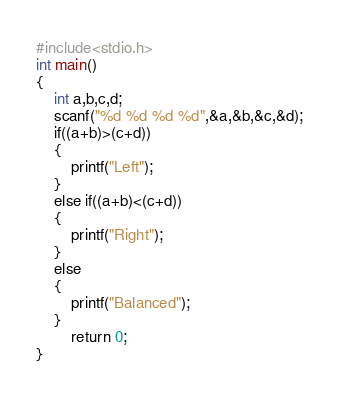Convert code to text. <code><loc_0><loc_0><loc_500><loc_500><_C_>#include<stdio.h>
int main()
{
    int a,b,c,d;
    scanf("%d %d %d %d",&a,&b,&c,&d);
    if((a+b)>(c+d))
    {
        printf("Left");
    }
    else if((a+b)<(c+d))
    {
        printf("Right");
    }
    else
    {
        printf("Balanced");
    }
        return 0;
}
</code> 